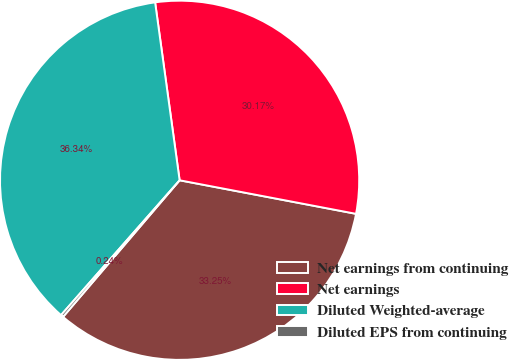<chart> <loc_0><loc_0><loc_500><loc_500><pie_chart><fcel>Net earnings from continuing<fcel>Net earnings<fcel>Diluted Weighted-average<fcel>Diluted EPS from continuing<nl><fcel>33.25%<fcel>30.17%<fcel>36.34%<fcel>0.24%<nl></chart> 